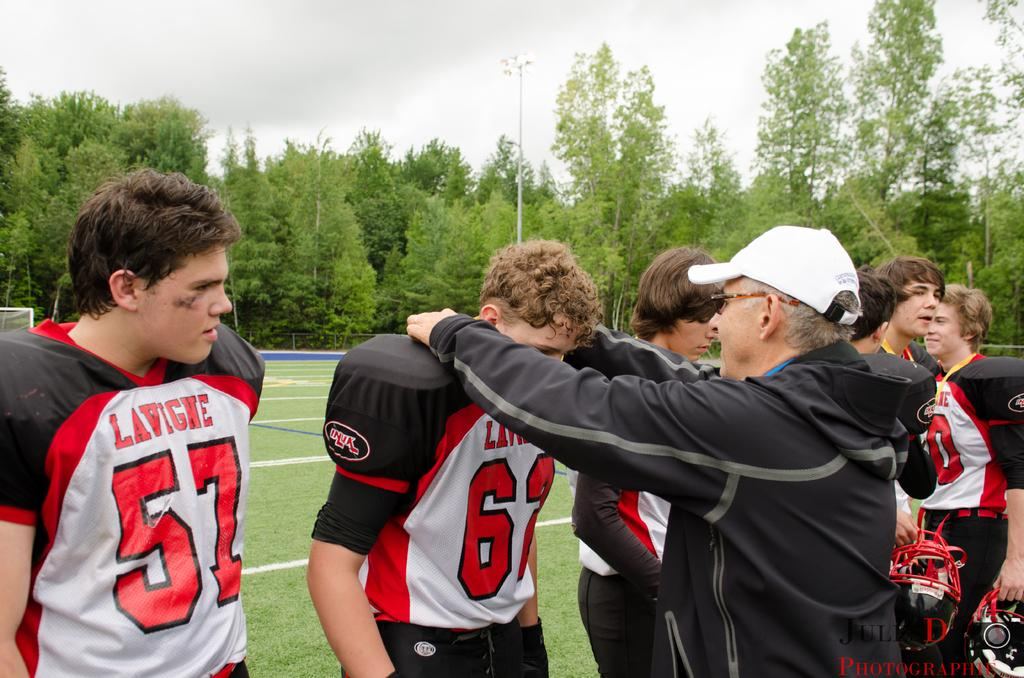<image>
Provide a brief description of the given image. A football player is has the number 57 on his jersey. 